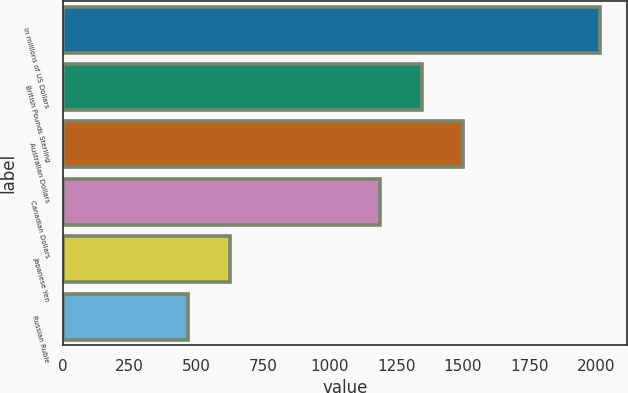<chart> <loc_0><loc_0><loc_500><loc_500><bar_chart><fcel>In millions of US Dollars<fcel>British Pounds Sterling<fcel>Australian Dollars<fcel>Canadian Dollars<fcel>Japanese Yen<fcel>Russian Ruble<nl><fcel>2016<fcel>1344.6<fcel>1499.2<fcel>1190<fcel>624.6<fcel>470<nl></chart> 